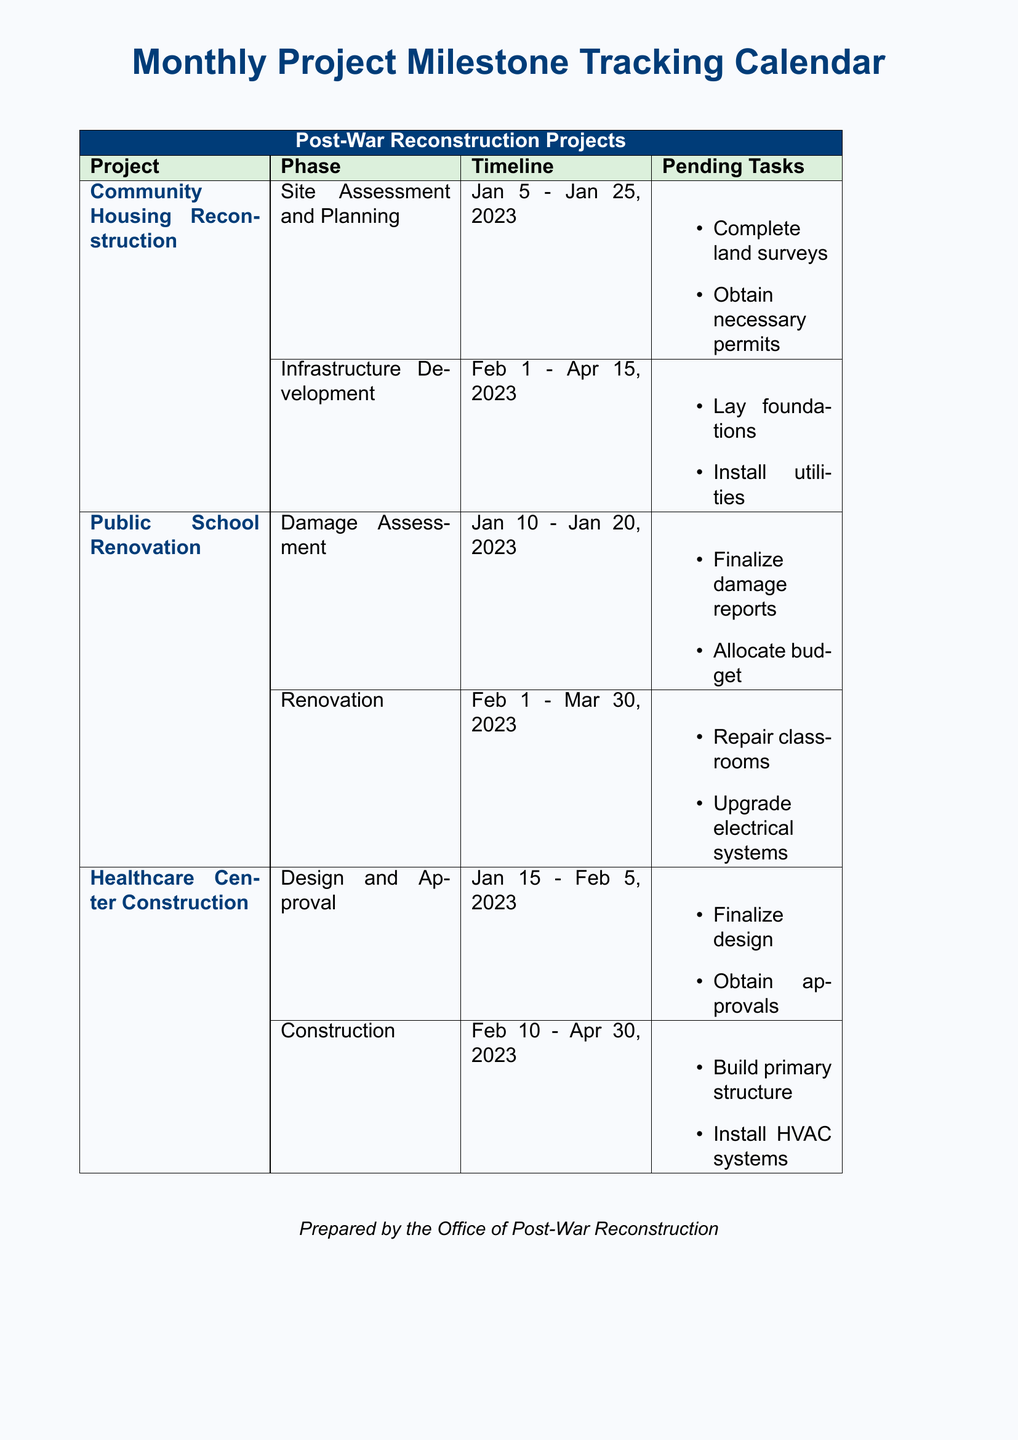What is the start date for the Community Housing Reconstruction project? The start date is specifically listed under the Community Housing Reconstruction project phase, which is January 5, 2023.
Answer: January 5, 2023 How many phases are there for the Public School Renovation project? The Public School Renovation project has two distinct phases outlined in the document: Damage Assessment and Renovation.
Answer: 2 What task is pending for the Healthcare Center Construction's Design and Approval phase? Pending tasks are clearly listed under each phase; for the Design and Approval phase, one task is to finalize the design.
Answer: Finalize design What is the completion date of the Infrastructure Development phase? The completion date is provided in the timeline for the Infrastructure Development phase of the Community Housing Reconstruction project, which is April 15, 2023.
Answer: April 15, 2023 Which team is responsible for obtaining approvals in the Healthcare Center Construction project? The team responsible for obtaining approvals is implicitly the project team managing the Design and Approval phase; the document does not specify a name.
Answer: Project team What are the two pending tasks for the Public School Renovation's Renovation phase? The tasks are listed clearly in the document: repair classrooms and upgrade electrical systems.
Answer: Repair classrooms, upgrade electrical systems What project has the earliest start date? The start dates for each project indicate that the Community Housing Reconstruction project begins on January 5, 2023, making it the earliest.
Answer: Community Housing Reconstruction How many pending tasks are listed for the Community Housing Reconstruction's Infrastructure Development phase? The number of pending tasks is counted directly from the list provided under that phase; there are two tasks listed.
Answer: 2 What is the main color theme of the document? The color theme as seen in the headers and backgrounds is primarily light blue and dark blue.
Answer: Light blue and dark blue 